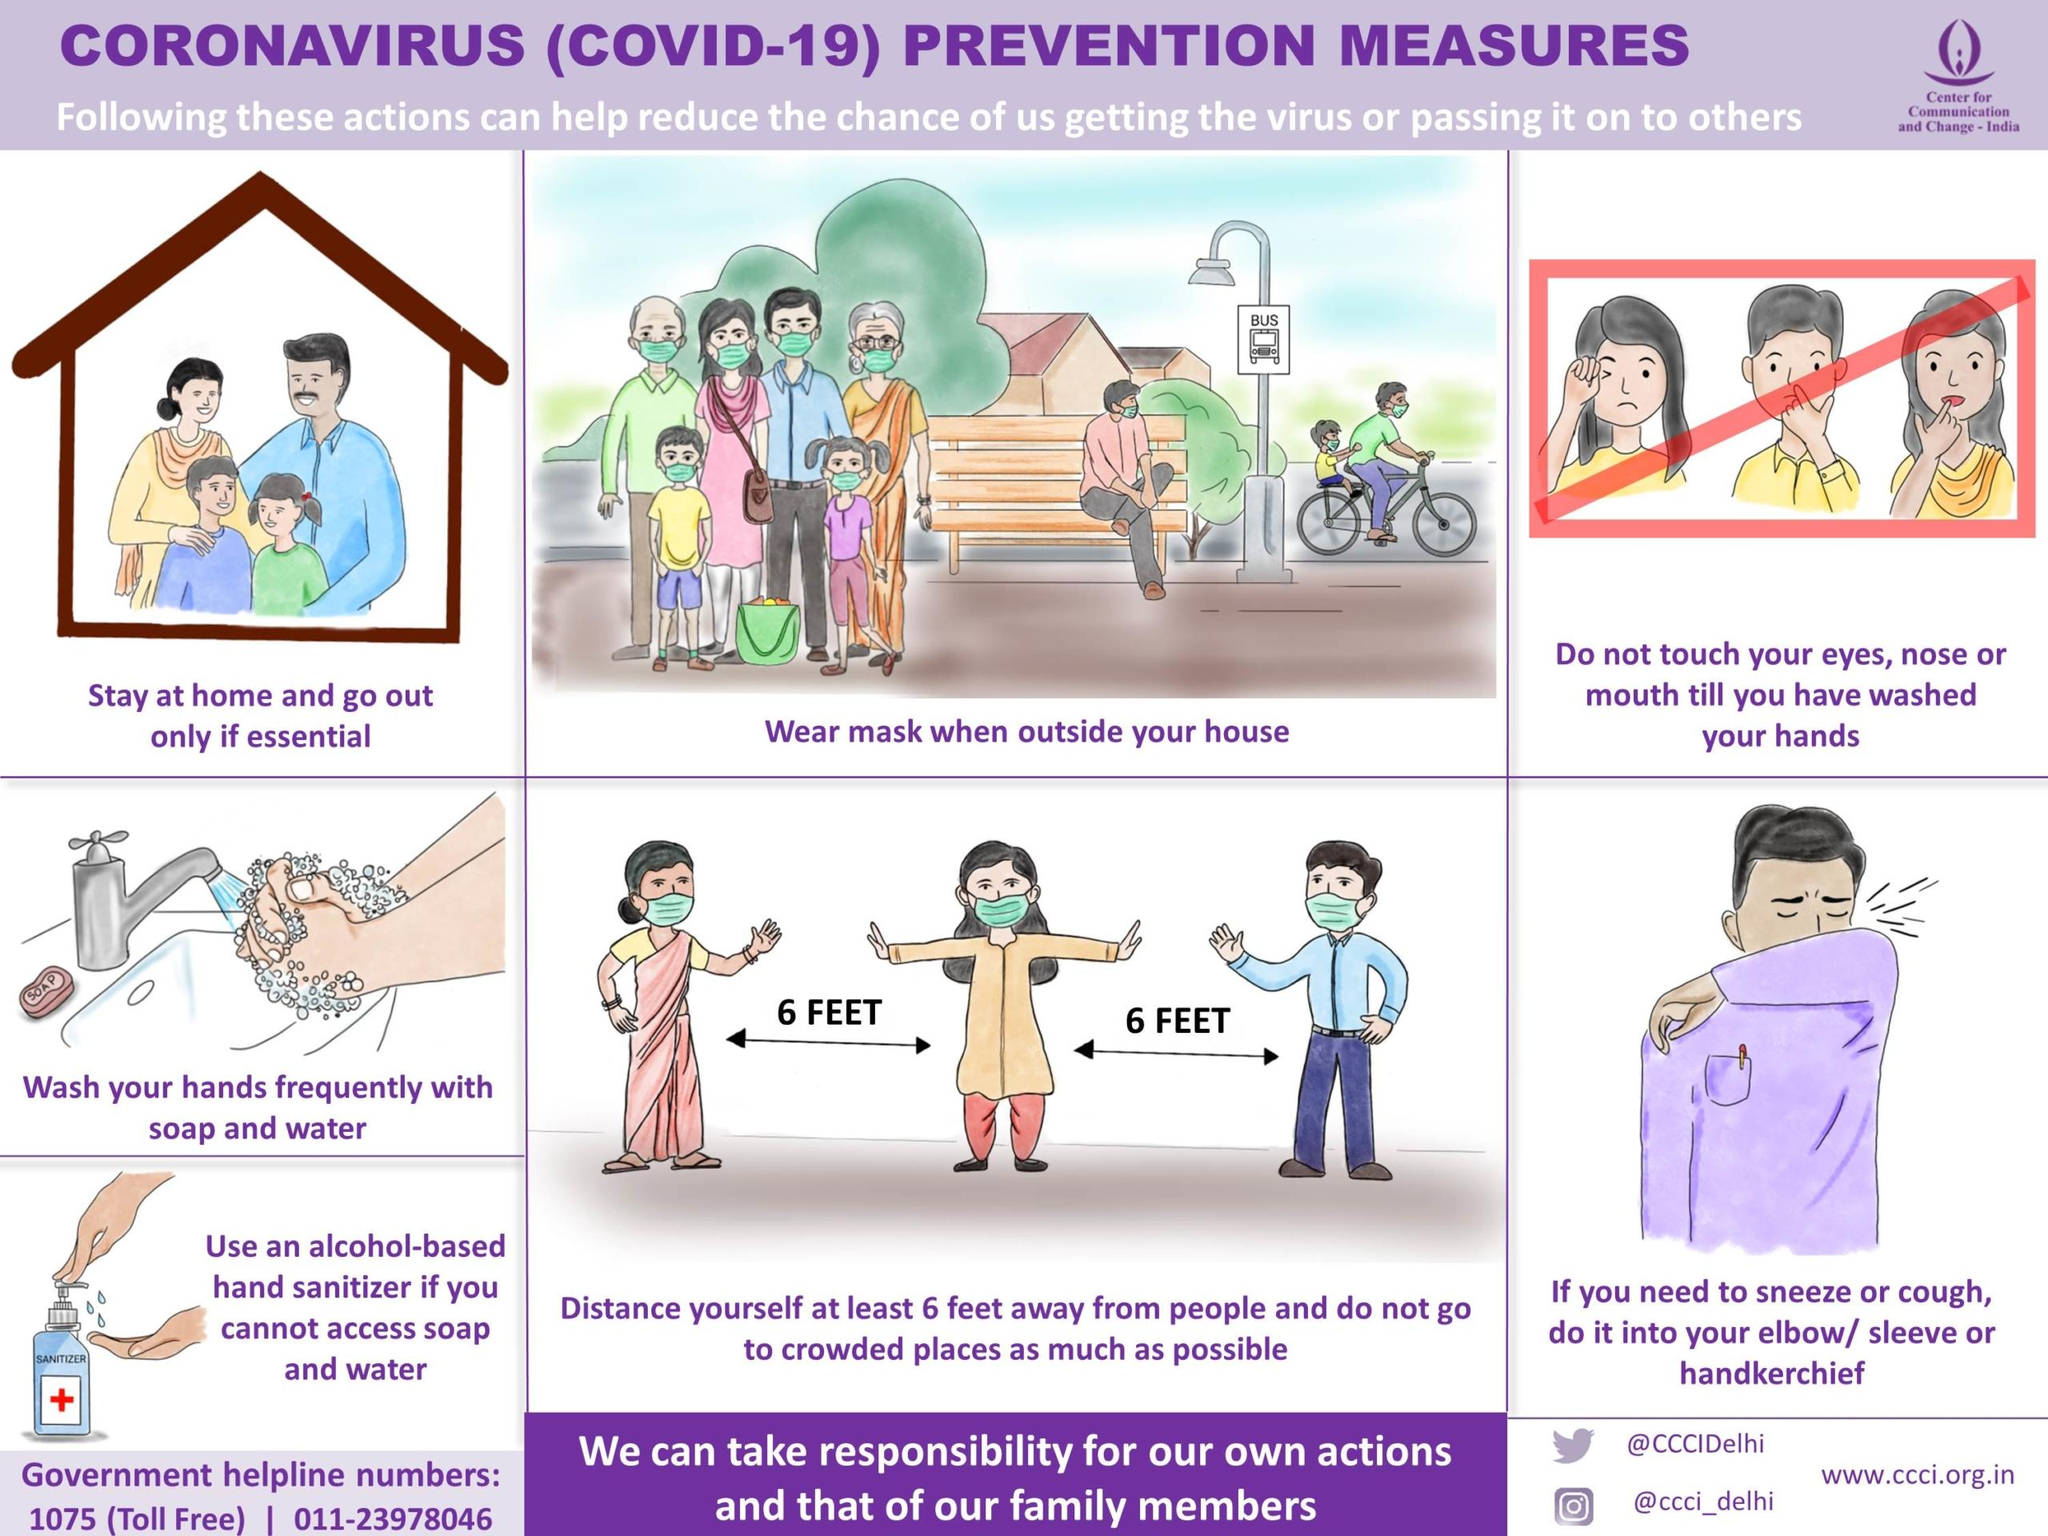Point out several critical features in this image. There are 7 measures outlined in this infographic aimed at preventing the spread of coronavirus. The parts of the face are the eyes, nose, and mouth. In this infographic, there is one bottle of sanitizer. 